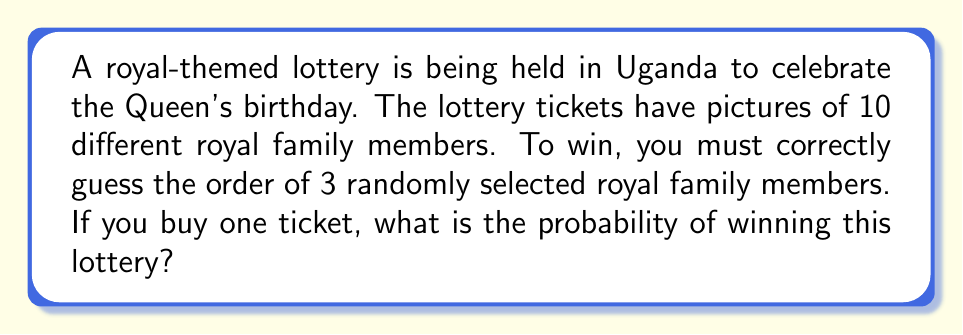Help me with this question. Let's approach this step-by-step:

1) First, we need to understand what we're calculating. We're looking for the probability of correctly guessing the order of 3 royal family members out of 10 possible choices.

2) This is a permutation problem. We're selecting 3 items from 10, where the order matters.

3) The total number of possible permutations is given by the formula:

   $$P(10,3) = \frac{10!}{(10-3)!} = \frac{10!}{7!}$$

4) Let's calculate this:
   
   $$\frac{10!}{7!} = \frac{10 * 9 * 8 * 7!}{7!} = 10 * 9 * 8 = 720$$

5) This means there are 720 possible outcomes.

6) The probability of winning is the number of favorable outcomes (which is 1, as there's only one correct order) divided by the total number of possible outcomes:

   $$P(\text{winning}) = \frac{1}{720}$$

7) To express this as a decimal, we divide 1 by 720:

   $$\frac{1}{720} \approx 0.001389$$

8) To express as a percentage, we multiply by 100:

   $$0.001389 * 100\% \approx 0.1389\%$$
Answer: $\frac{1}{720}$ or approximately $0.1389\%$ 